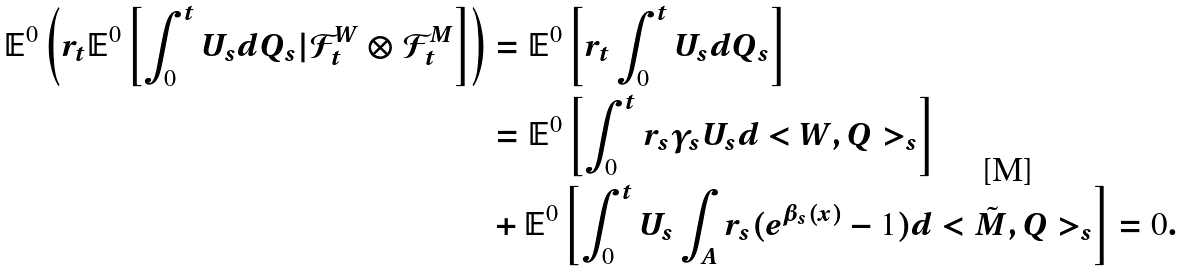Convert formula to latex. <formula><loc_0><loc_0><loc_500><loc_500>\mathbb { E } ^ { 0 } \left ( r _ { t } \mathbb { E } ^ { 0 } \left [ \int _ { 0 } ^ { t } U _ { s } d Q _ { s } | \mathcal { F } _ { t } ^ { W } \otimes \mathcal { F } _ { t } ^ { M } \right ] \right ) & = \mathbb { E } ^ { 0 } \left [ r _ { t } \int _ { 0 } ^ { t } U _ { s } d Q _ { s } \right ] \\ & = \mathbb { E } ^ { 0 } \left [ \int _ { 0 } ^ { t } r _ { s } \gamma _ { s } U _ { s } d < W , Q > _ { s } \right ] \\ & + \mathbb { E } ^ { 0 } \left [ \int _ { 0 } ^ { t } U _ { s } \int _ { A } r _ { s } ( e ^ { \beta _ { s } ( x ) } - 1 ) d < \tilde { M } , Q > _ { s } \right ] = 0 .</formula> 